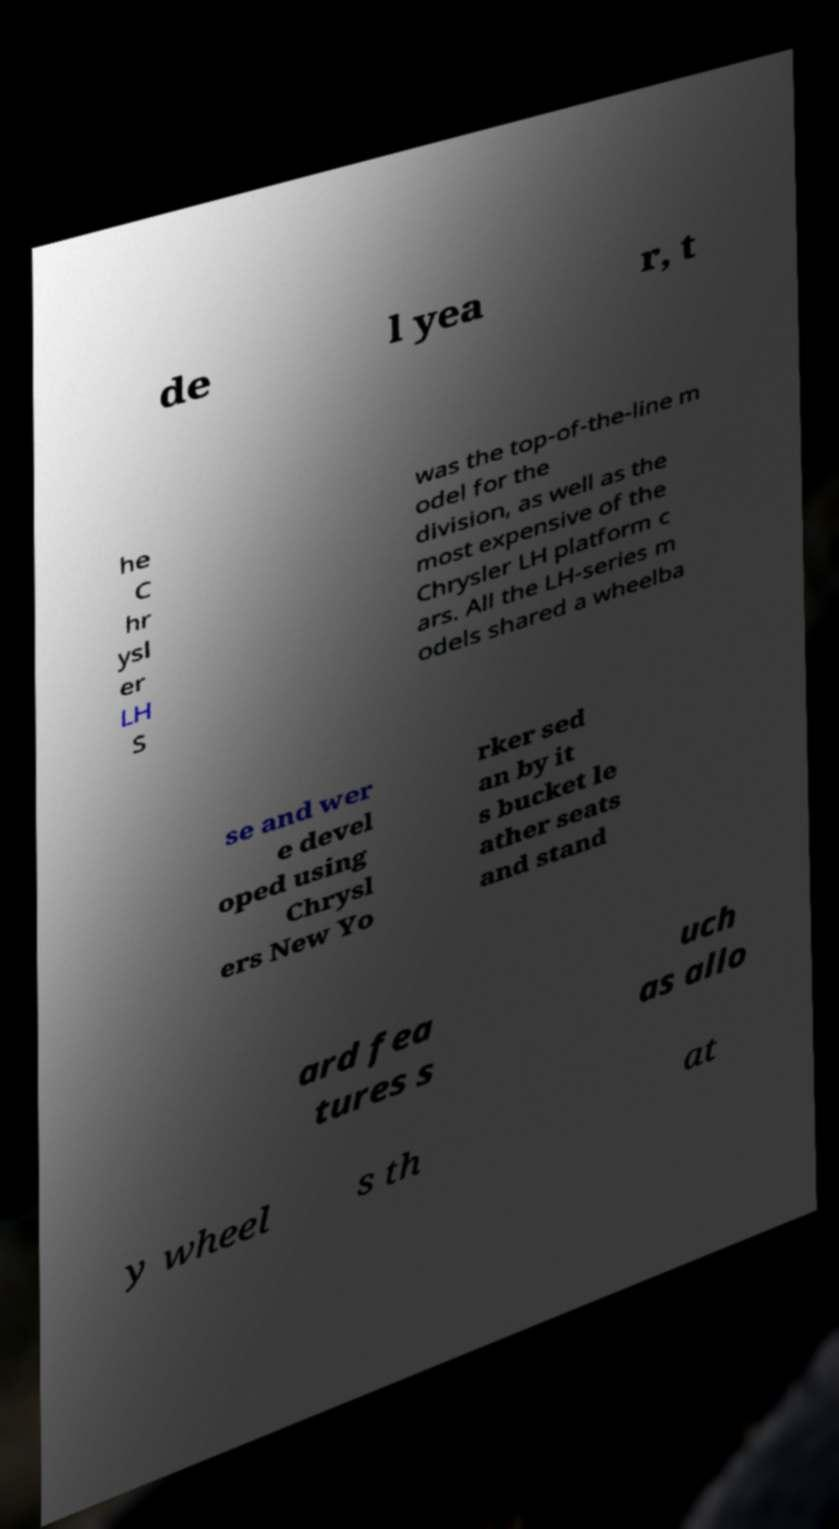Please identify and transcribe the text found in this image. de l yea r, t he C hr ysl er LH S was the top-of-the-line m odel for the division, as well as the most expensive of the Chrysler LH platform c ars. All the LH-series m odels shared a wheelba se and wer e devel oped using Chrysl ers New Yo rker sed an by it s bucket le ather seats and stand ard fea tures s uch as allo y wheel s th at 